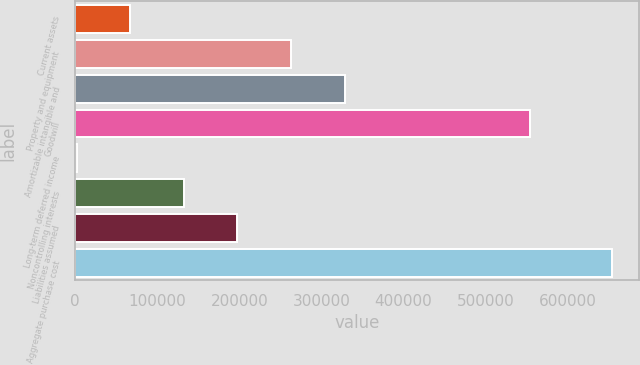<chart> <loc_0><loc_0><loc_500><loc_500><bar_chart><fcel>Current assets<fcel>Property and equipment<fcel>Amortizable intangible and<fcel>Goodwill<fcel>Long-term deferred income<fcel>Noncontrolling interests<fcel>Liabilities assumed<fcel>Aggregate purchase cost<nl><fcel>67096.1<fcel>262870<fcel>328128<fcel>554685<fcel>1838<fcel>132354<fcel>197612<fcel>654419<nl></chart> 